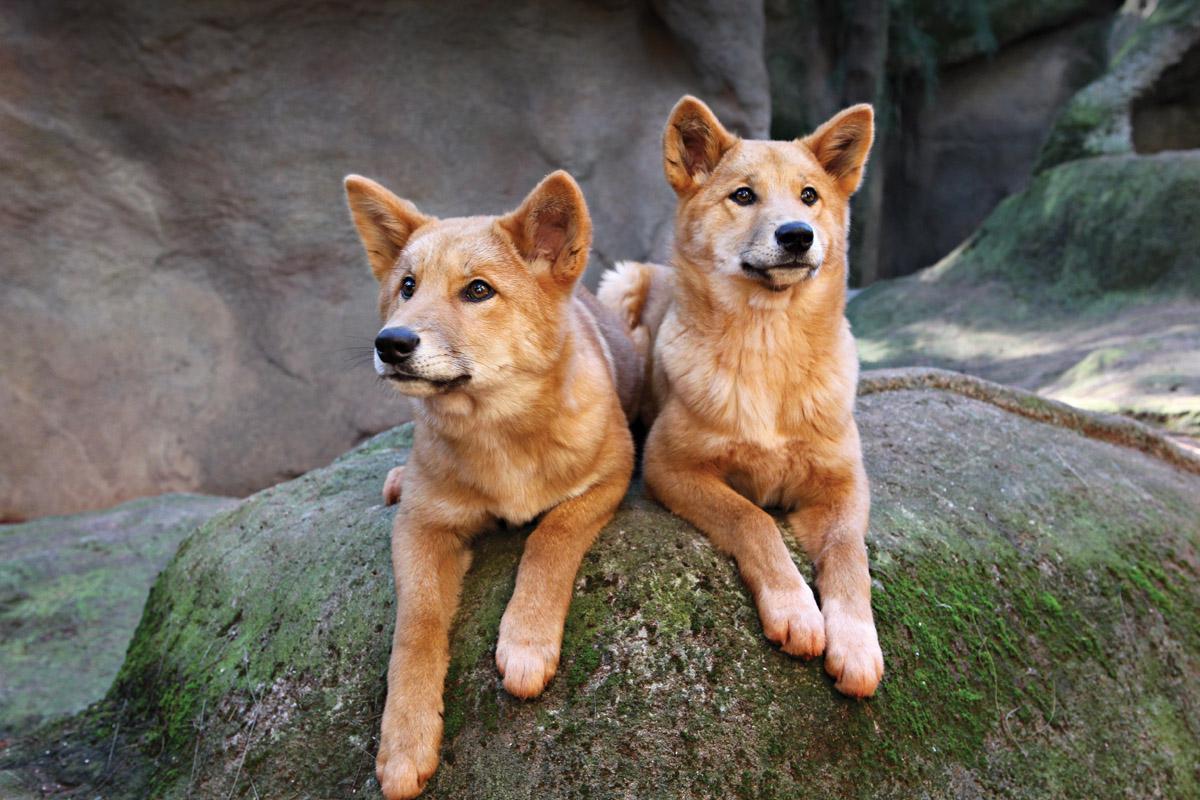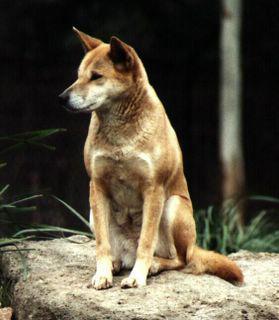The first image is the image on the left, the second image is the image on the right. Given the left and right images, does the statement "An image shows one dog sitting upright on a rock, with its head and gaze angled leftward." hold true? Answer yes or no. Yes. The first image is the image on the left, the second image is the image on the right. Analyze the images presented: Is the assertion "There are exactly two canines, outdoors." valid? Answer yes or no. No. 